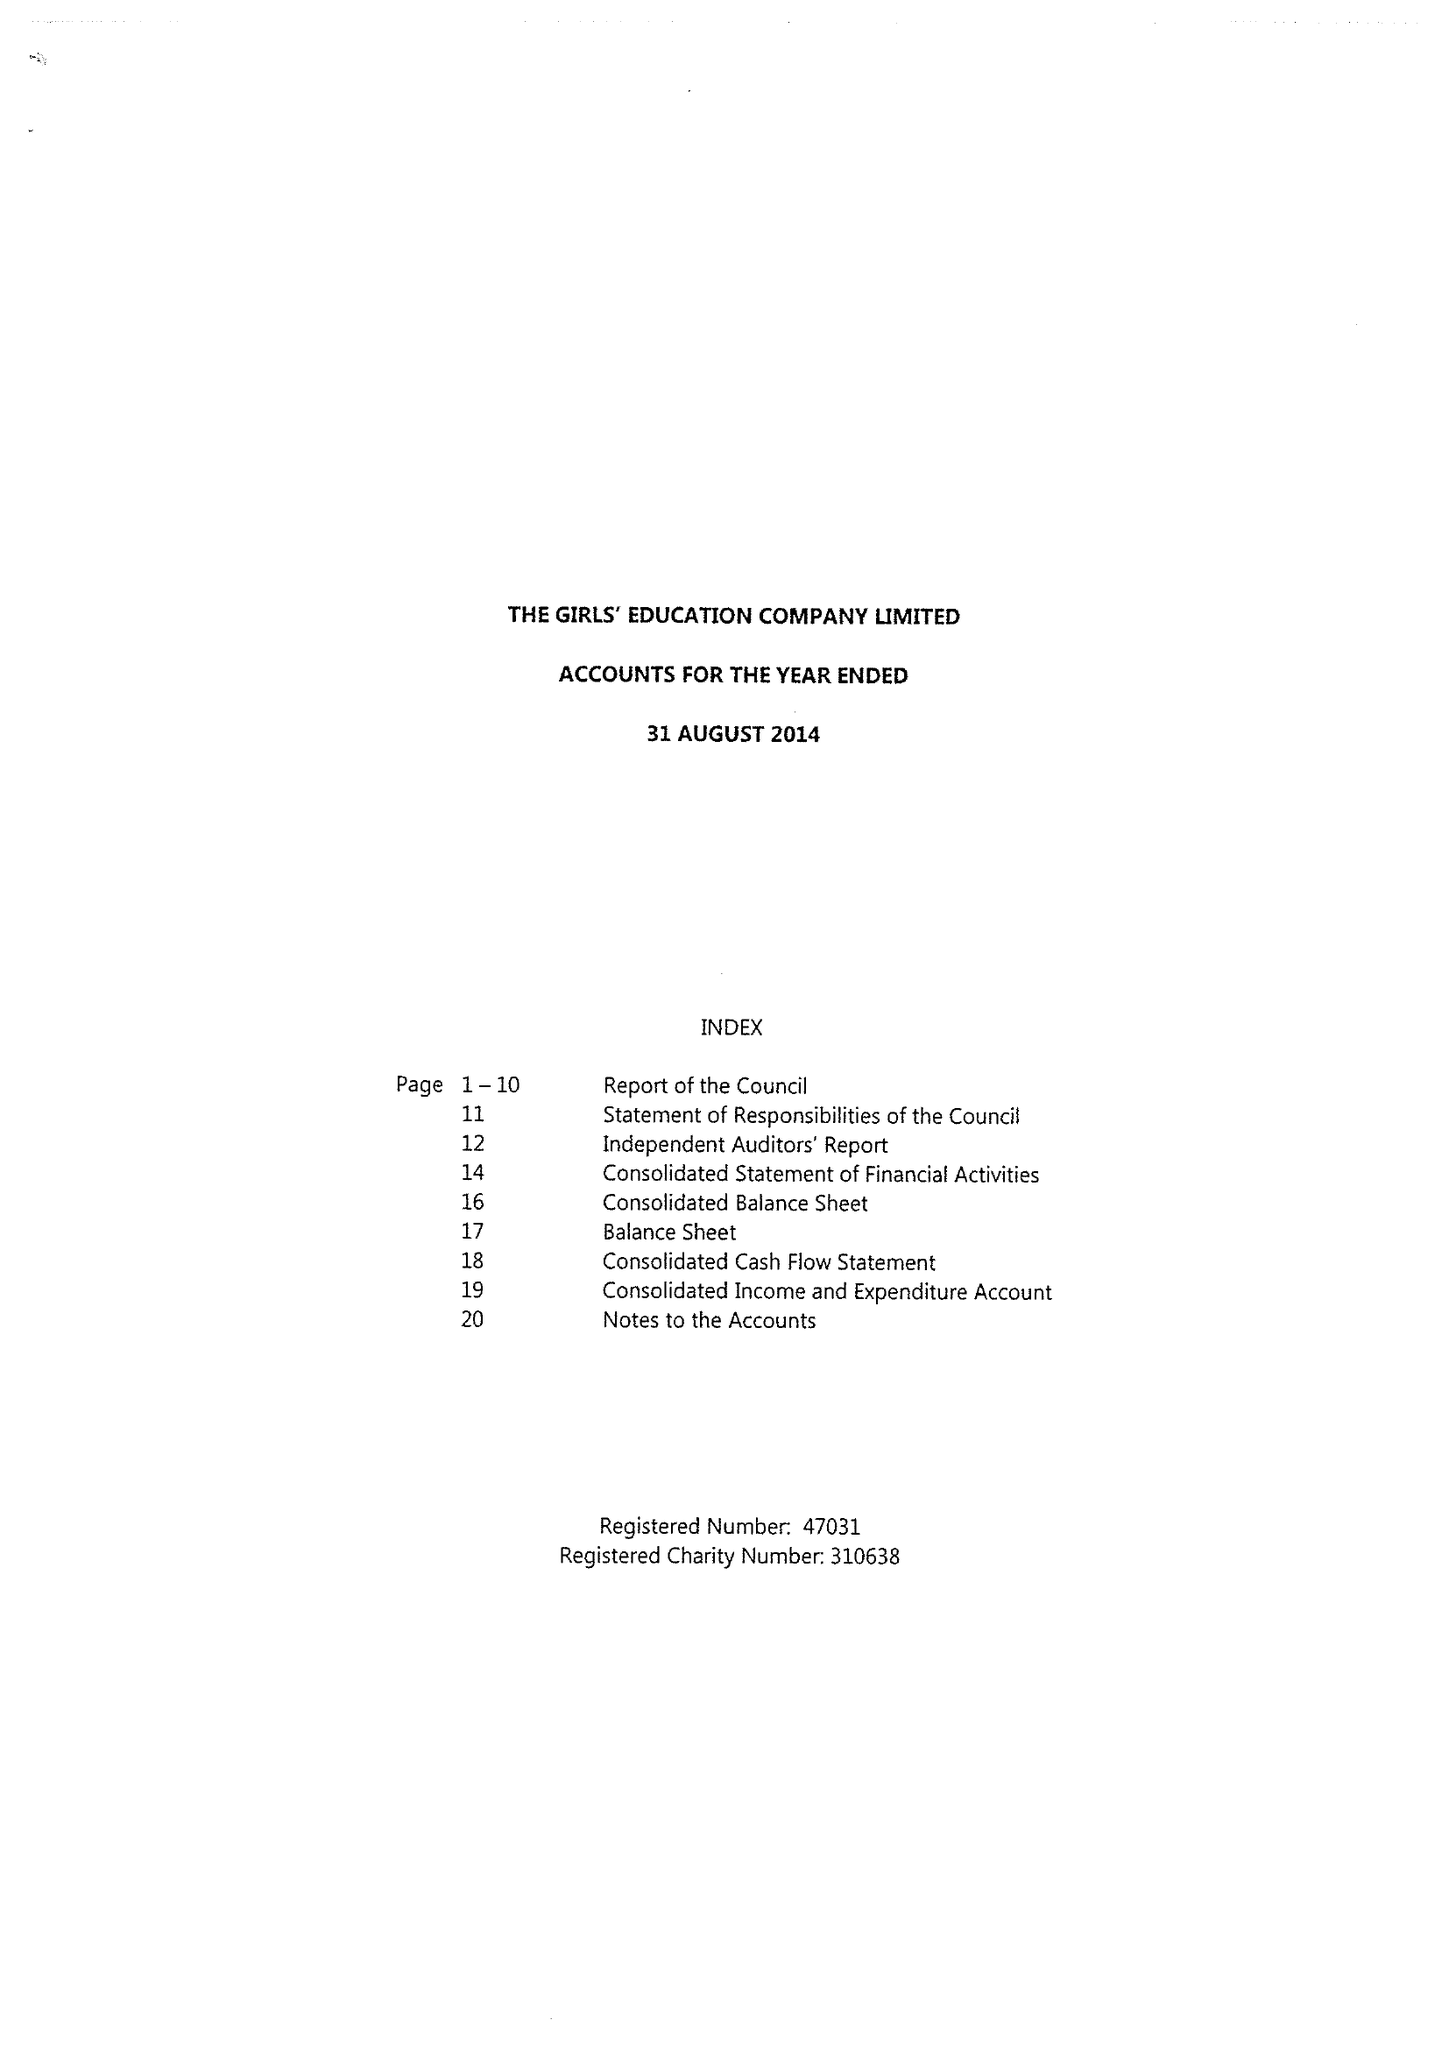What is the value for the income_annually_in_british_pounds?
Answer the question using a single word or phrase. 20711779.00 